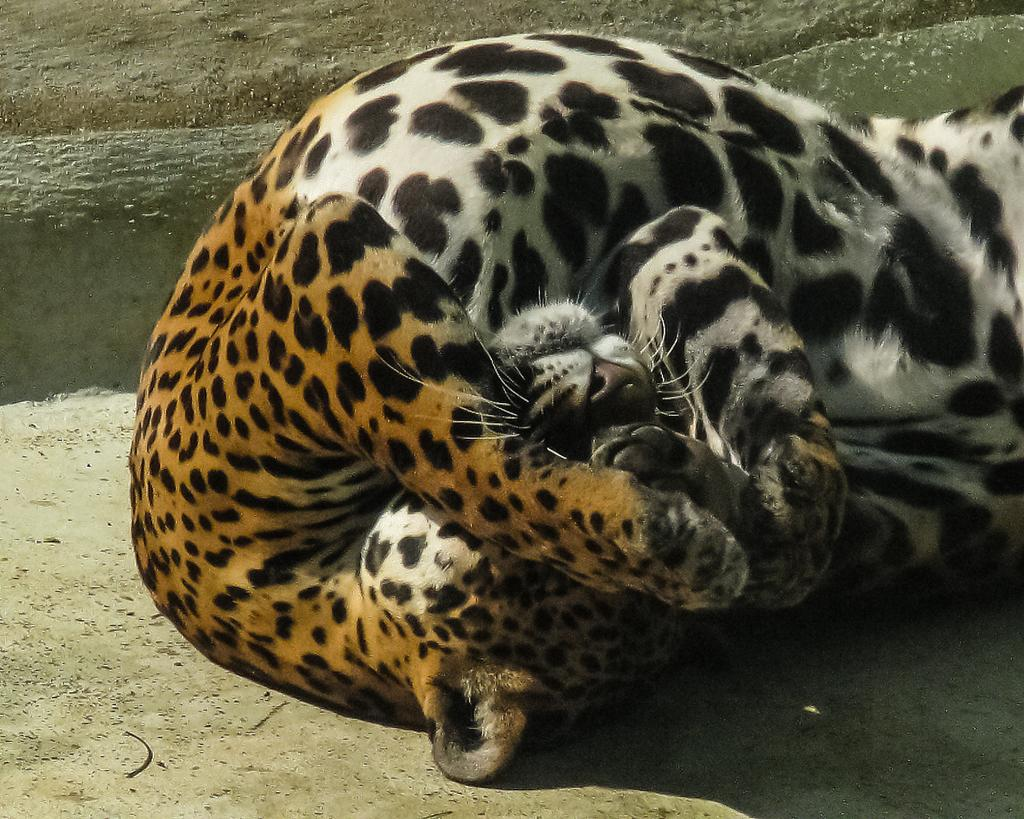What type of creature can be seen in the image? There is a wild animal in the image. Where is the wild animal located? The wild animal is on the ground. What color is the paint on the boys' seats in the image? There are no boys or seats present in the image, so there is no paint to describe. 